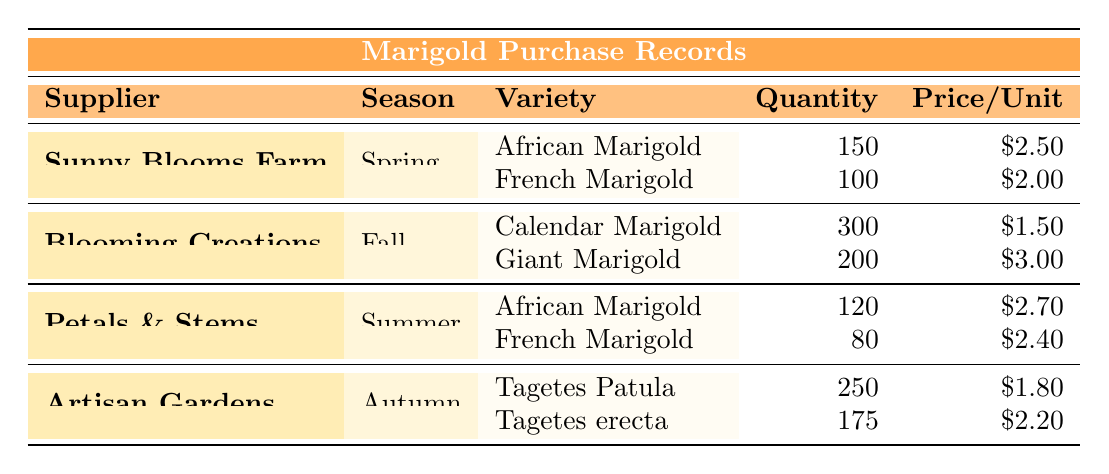What is the total quantity of African Marigolds purchased? From the table, there are two suppliers providing African Marigolds: Sunny Blooms Farm (150) and Petals & Stems (120). To find the total quantity, we add these two values: 150 + 120 = 270.
Answer: 270 Which supplier provided French Marigolds in Spring? The table shows that Sunny Blooms Farm provided French Marigolds during the Spring season with a quantity of 100.
Answer: Sunny Blooms Farm How many units of Giant Marigold were purchased? According to the table, Blooming Creations provided 200 units of Giant Marigolds in Fall.
Answer: 200 Is it true that Petals & Stems provided more Marigolds than Artisan Gardens? To verify, we check the total purchases: Petals & Stems provided 120 (African) + 80 (French) = 200 Marigolds. Artisan Gardens provided 250 (Tagetes Patula) + 175 (Tagetes erecta) = 425 Marigolds. Since 200 is less than 425, the statement is false.
Answer: False What is the average price per unit for Marigolds purchased from Artisan Gardens? Artisan Gardens provided two varieties: Tagetes Patula at $1.80 and Tagetes erecta at $2.20. To find the average, we sum the prices: 1.80 + 2.20 = 4.00, then divide by the number of varieties (2): 4.00 / 2 = 2.00.
Answer: 2.00 Which season had the highest quantity of Marigolds purchased? We compare total quantities from all seasons: Spring (150 + 100 = 250), Fall (300 + 200 = 500), Summer (120 + 80 = 200), and Autumn (250 + 175 = 425). The highest quantity is 500 from Fall.
Answer: Fall How many more Calendar Marigolds were purchased compared to French Marigolds from Petals & Stems? Calendar Marigolds purchased were 300 (Blooming Creations) and French Marigolds from Petals & Stems were 80. The difference is calculated as 300 - 80 = 220.
Answer: 220 Was the price per unit for French Marigold higher from Sunny Blooms Farm or Petals & Stems? The price for French Marigold from Sunny Blooms Farm is $2.00, while from Petals & Stems it is $2.40. Since $2.40 is greater than $2.00, the price was higher from Petals & Stems.
Answer: Petals & Stems 